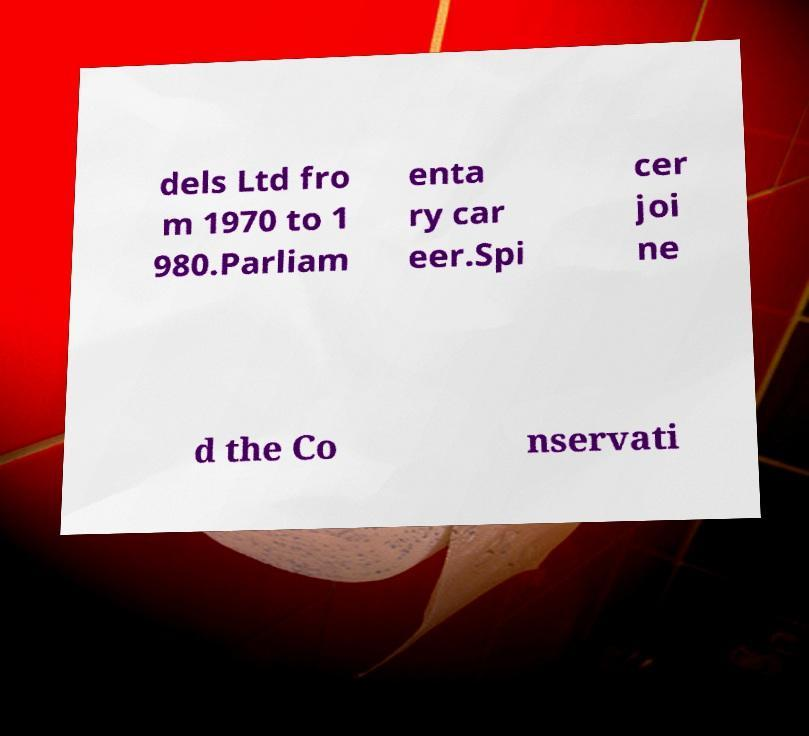What messages or text are displayed in this image? I need them in a readable, typed format. dels Ltd fro m 1970 to 1 980.Parliam enta ry car eer.Spi cer joi ne d the Co nservati 